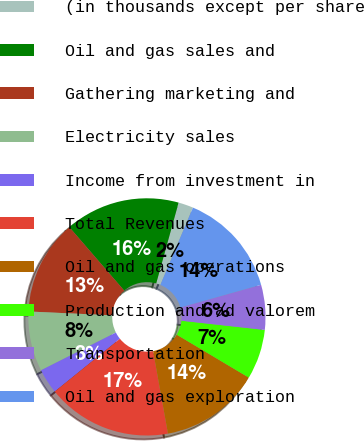<chart> <loc_0><loc_0><loc_500><loc_500><pie_chart><fcel>(in thousands except per share<fcel>Oil and gas sales and<fcel>Gathering marketing and<fcel>Electricity sales<fcel>Income from investment in<fcel>Total Revenues<fcel>Oil and gas operations<fcel>Production and ad valorem<fcel>Transportation<fcel>Oil and gas exploration<nl><fcel>2.04%<fcel>15.65%<fcel>12.93%<fcel>8.16%<fcel>3.4%<fcel>17.01%<fcel>13.61%<fcel>6.8%<fcel>6.12%<fcel>14.29%<nl></chart> 